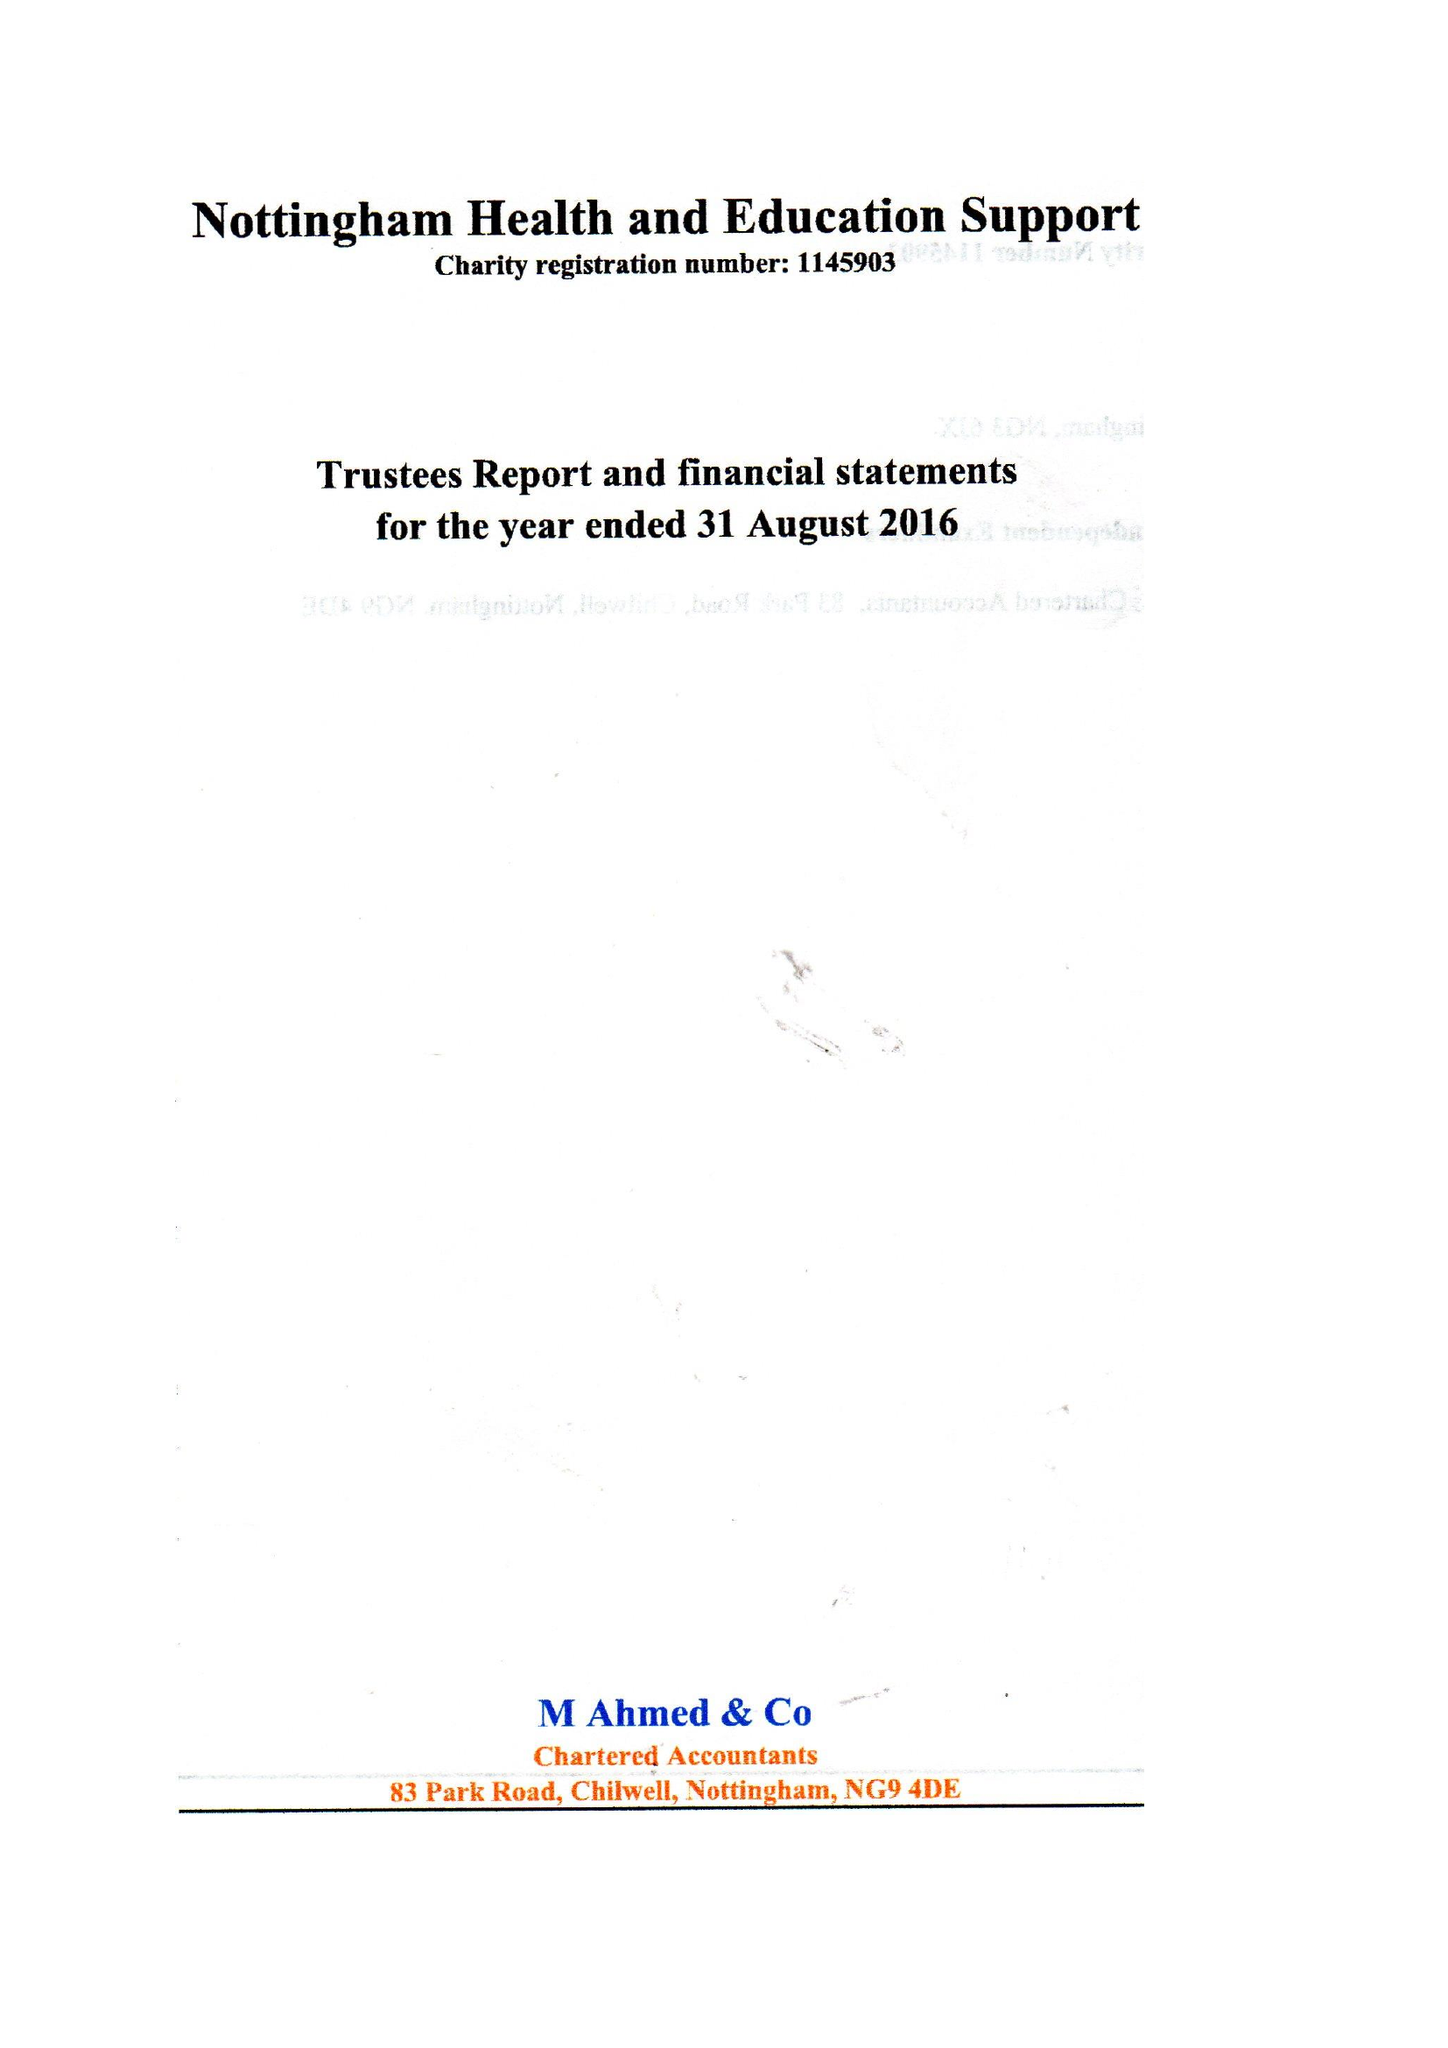What is the value for the charity_name?
Answer the question using a single word or phrase. Nottingham Health and Education Support 